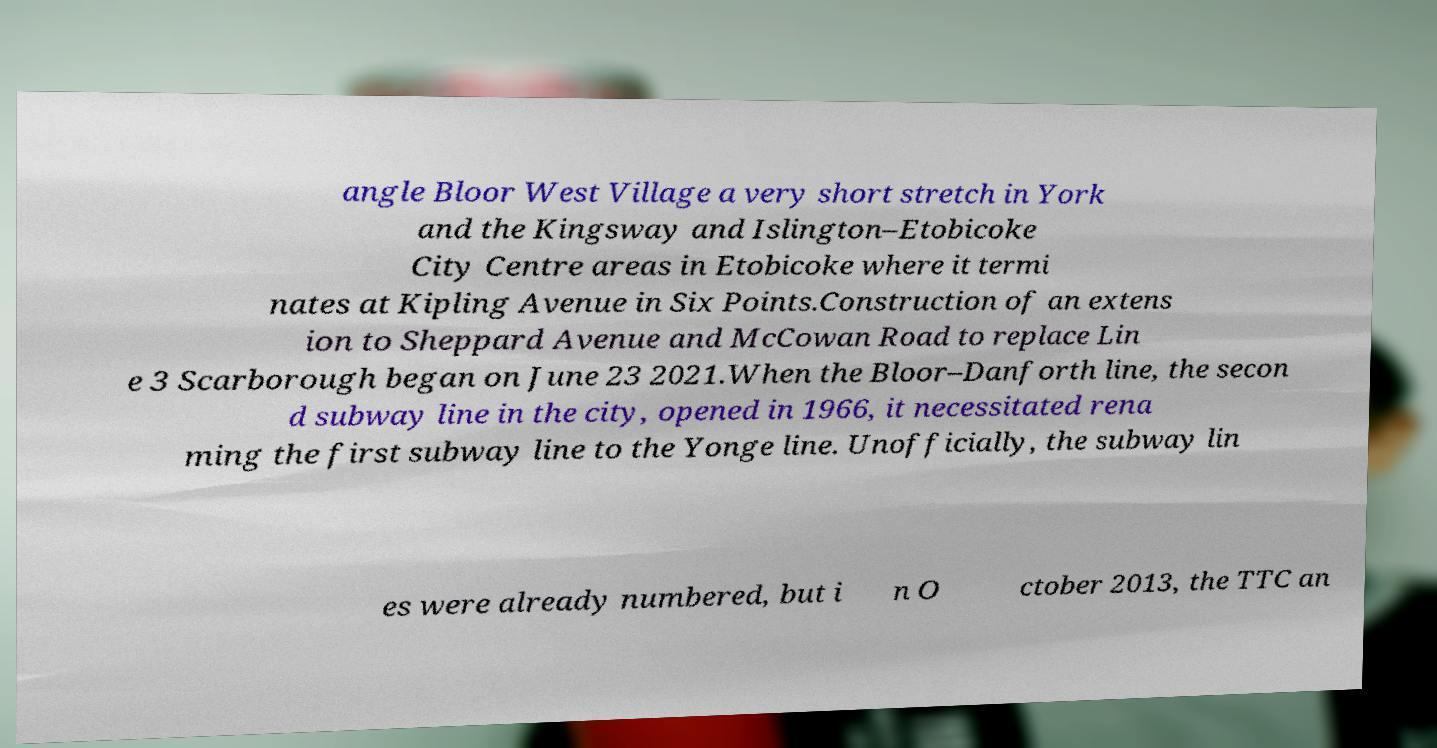For documentation purposes, I need the text within this image transcribed. Could you provide that? angle Bloor West Village a very short stretch in York and the Kingsway and Islington–Etobicoke City Centre areas in Etobicoke where it termi nates at Kipling Avenue in Six Points.Construction of an extens ion to Sheppard Avenue and McCowan Road to replace Lin e 3 Scarborough began on June 23 2021.When the Bloor–Danforth line, the secon d subway line in the city, opened in 1966, it necessitated rena ming the first subway line to the Yonge line. Unofficially, the subway lin es were already numbered, but i n O ctober 2013, the TTC an 